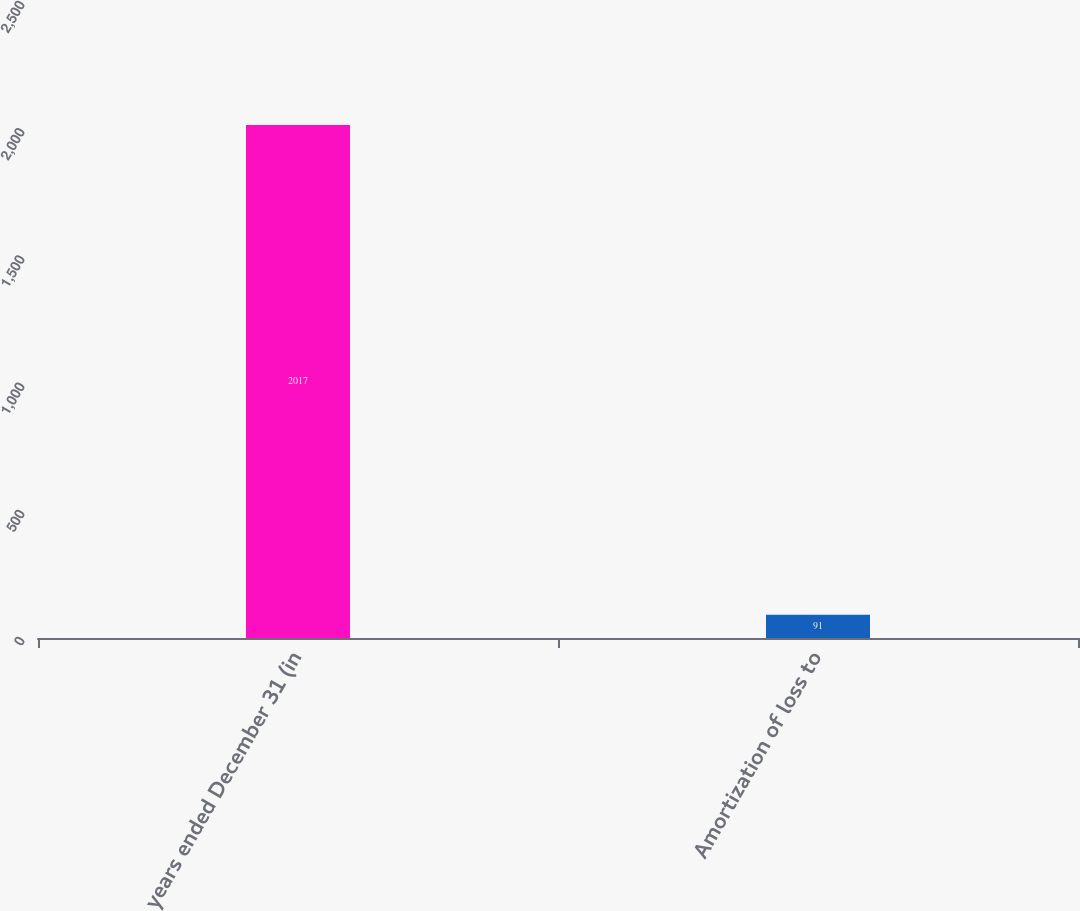Convert chart to OTSL. <chart><loc_0><loc_0><loc_500><loc_500><bar_chart><fcel>years ended December 31 (in<fcel>Amortization of loss to<nl><fcel>2017<fcel>91<nl></chart> 